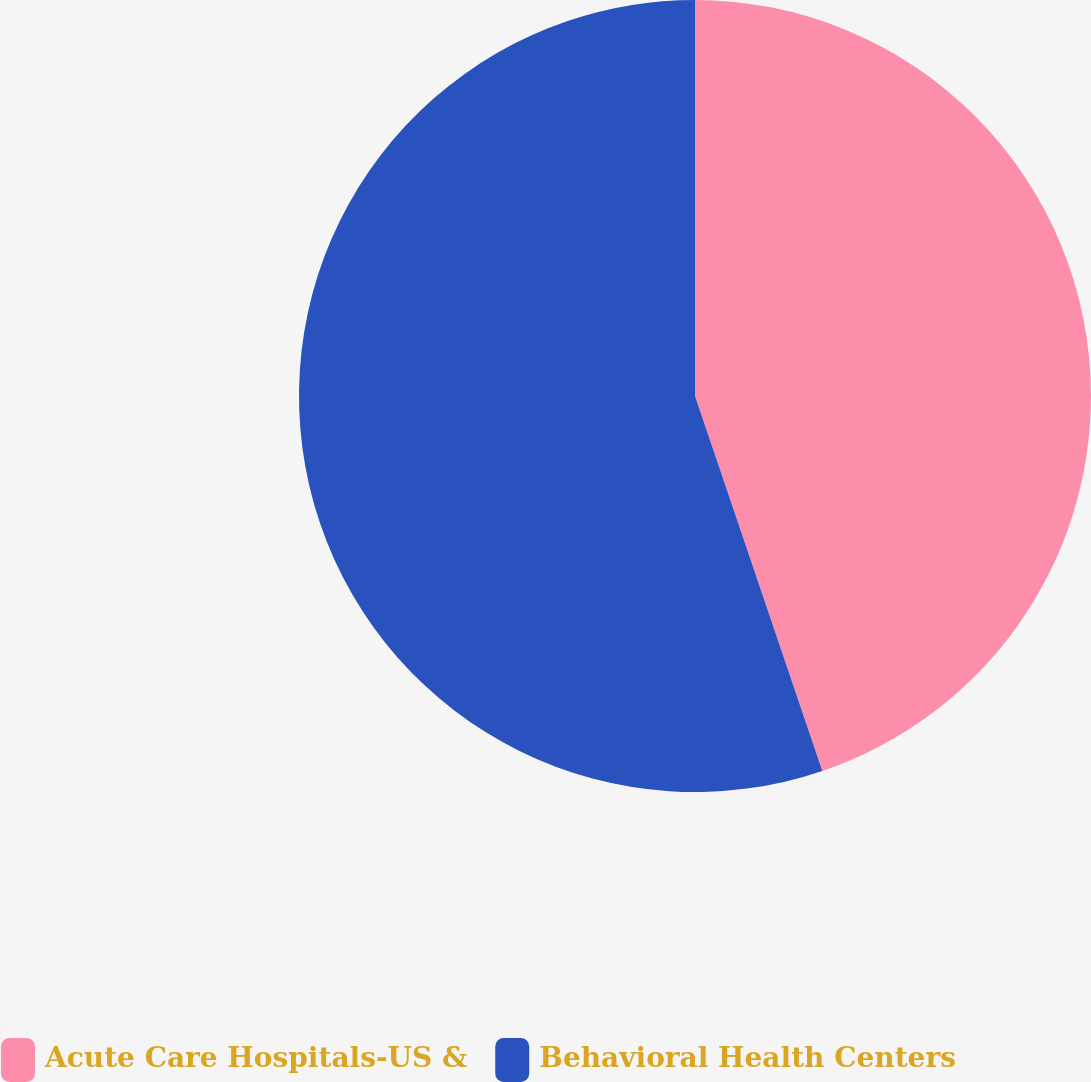Convert chart to OTSL. <chart><loc_0><loc_0><loc_500><loc_500><pie_chart><fcel>Acute Care Hospitals-US &<fcel>Behavioral Health Centers<nl><fcel>44.79%<fcel>55.21%<nl></chart> 